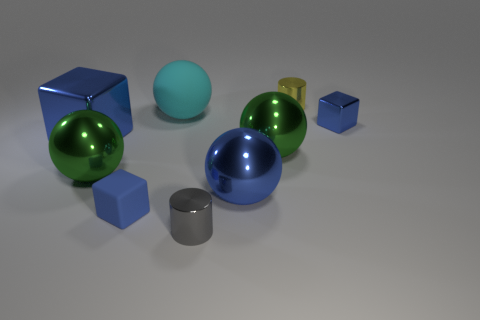Which object stands out the most? The green metallic ball stands out the most due to its vibrant color and shiny surface which reflects light, creating highlights that draw the eye. Why might that object stand out? The combination of its reflective surface, which allows it to catch light and cast reflections, and its bright, saturated color contrast sharply with the more subdued colors and textures of the other objects, making it a focal point. 